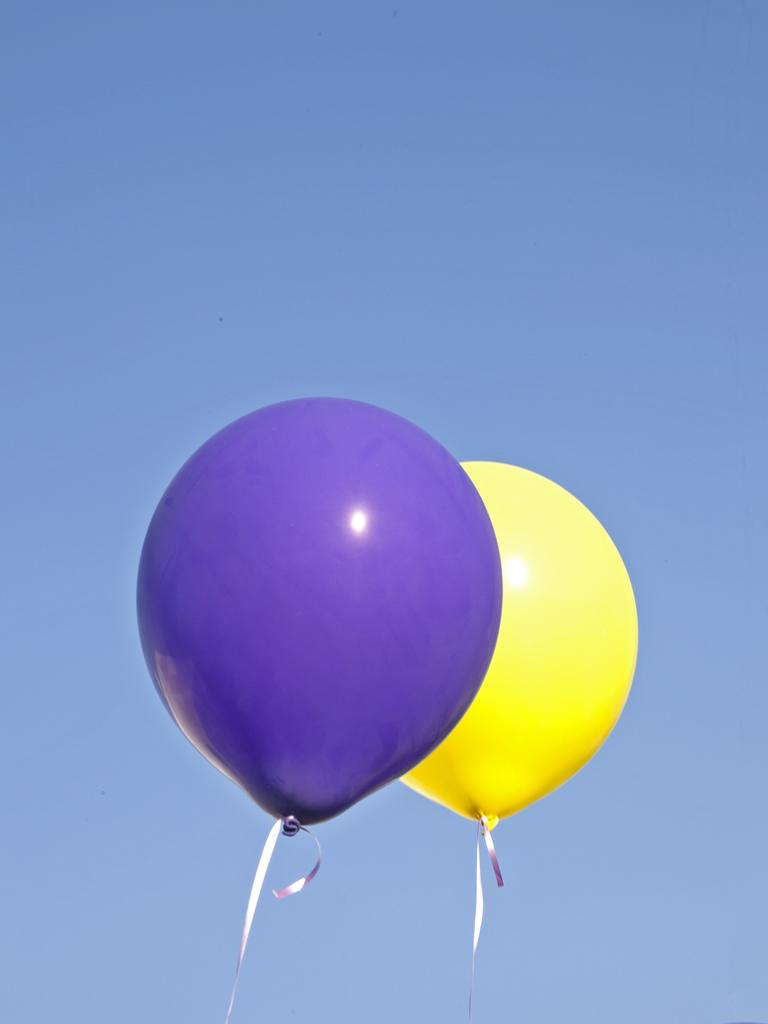How many balloons are in the picture? There are 2 balloons in the picture. What colors are the balloons? One balloon is purple, and the other is yellow. What can be seen in the background of the picture? The sky is visible in the background of the picture. What is the condition of the sky in the picture? The sky is clear in the picture. Is there a gate in the picture with a band playing behind it? No, there is no gate or band present in the image; it only features two balloons and a clear sky in the background. 